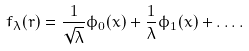<formula> <loc_0><loc_0><loc_500><loc_500>f _ { \lambda } ( r ) = \frac { 1 } { \sqrt { \lambda } } \phi _ { 0 } ( x ) + \frac { 1 } { \lambda } \phi _ { 1 } ( x ) + \dots .</formula> 